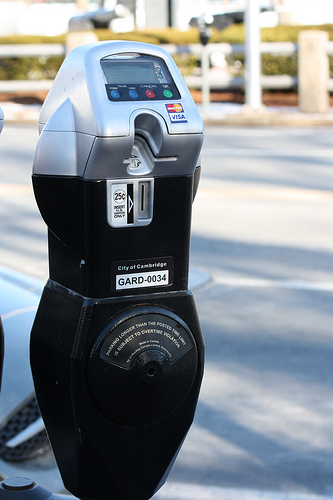Can you describe what the larger interface above the credit card and coin slots shows? The larger interface displays a digital screen and key pad area. The screen provides transaction details like amount to be paid and parking time, while the keypad is used for inputting payment or parking session details. 